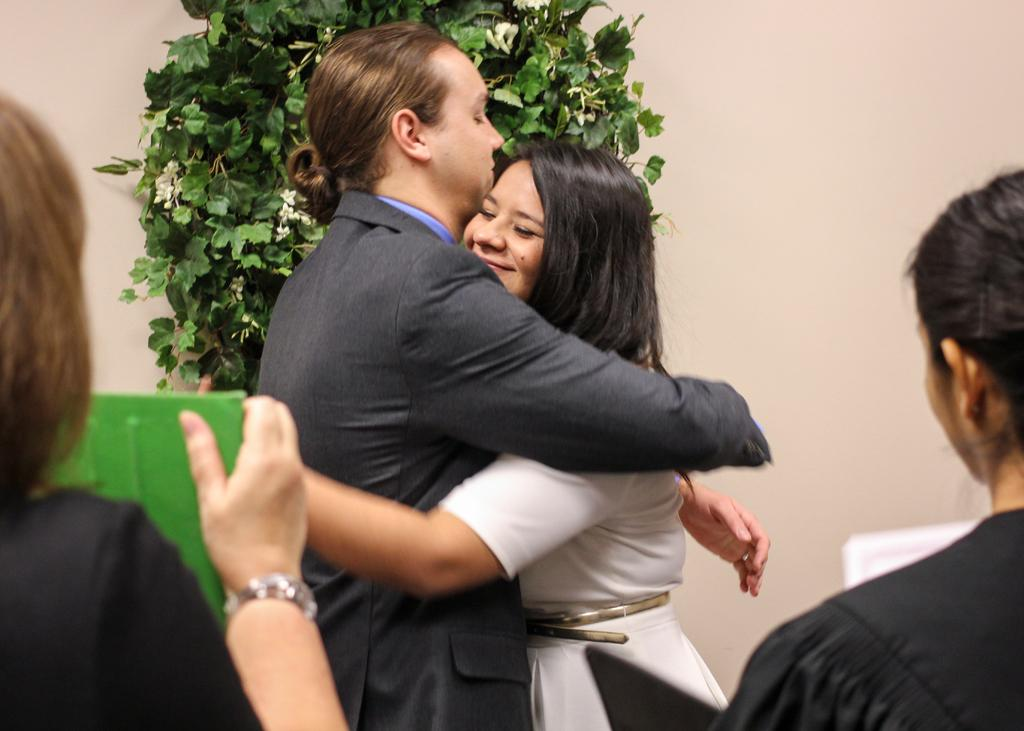How many people are in the image? There are people in the image, specifically two people who are hugging. What can be seen in the background of the image? There is a wall and a plant with flowers in the background of the image. What type of industry can be seen in the image? There is no industry present in the image; it features people hugging and a background with a wall and a plant with flowers. 